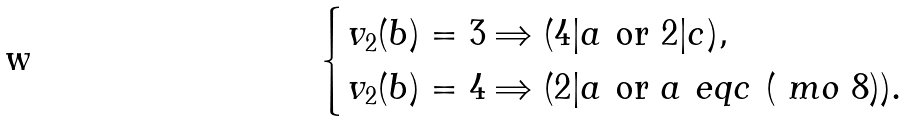Convert formula to latex. <formula><loc_0><loc_0><loc_500><loc_500>\begin{cases} v _ { 2 } ( b ) = 3 \Rightarrow ( 4 | a \ \text {or} \ 2 | c ) , & \\ v _ { 2 } ( b ) = 4 \Rightarrow ( 2 | a \ \text {or} \ a \ e q c \ ( \ m o \ 8 ) ) . \end{cases}</formula> 